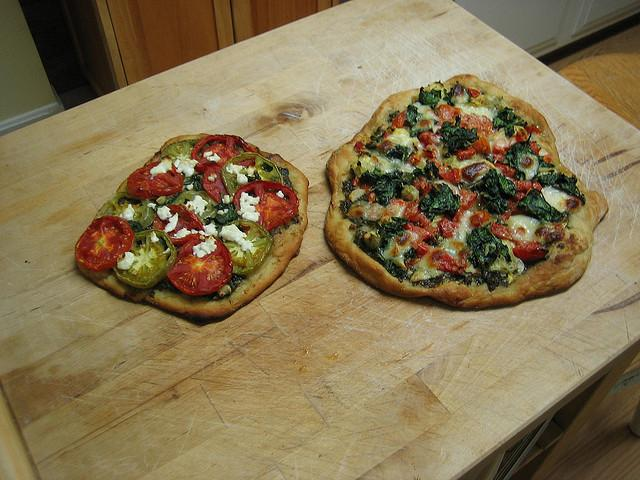What are the green vegetables next to the red tomatoes on the left-side pizza?

Choices:
A) snap peas
B) jalapenos
C) green tomatoes
D) broccoli green tomatoes 